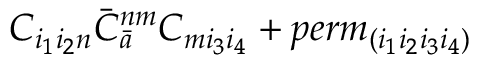<formula> <loc_0><loc_0><loc_500><loc_500>C _ { i _ { 1 } i _ { 2 } n } { \bar { C } } _ { \bar { a } } ^ { n m } C _ { m i _ { 3 } i _ { 4 } } + p e r m _ { ( i _ { 1 } i _ { 2 } i _ { 3 } i _ { 4 } ) }</formula> 